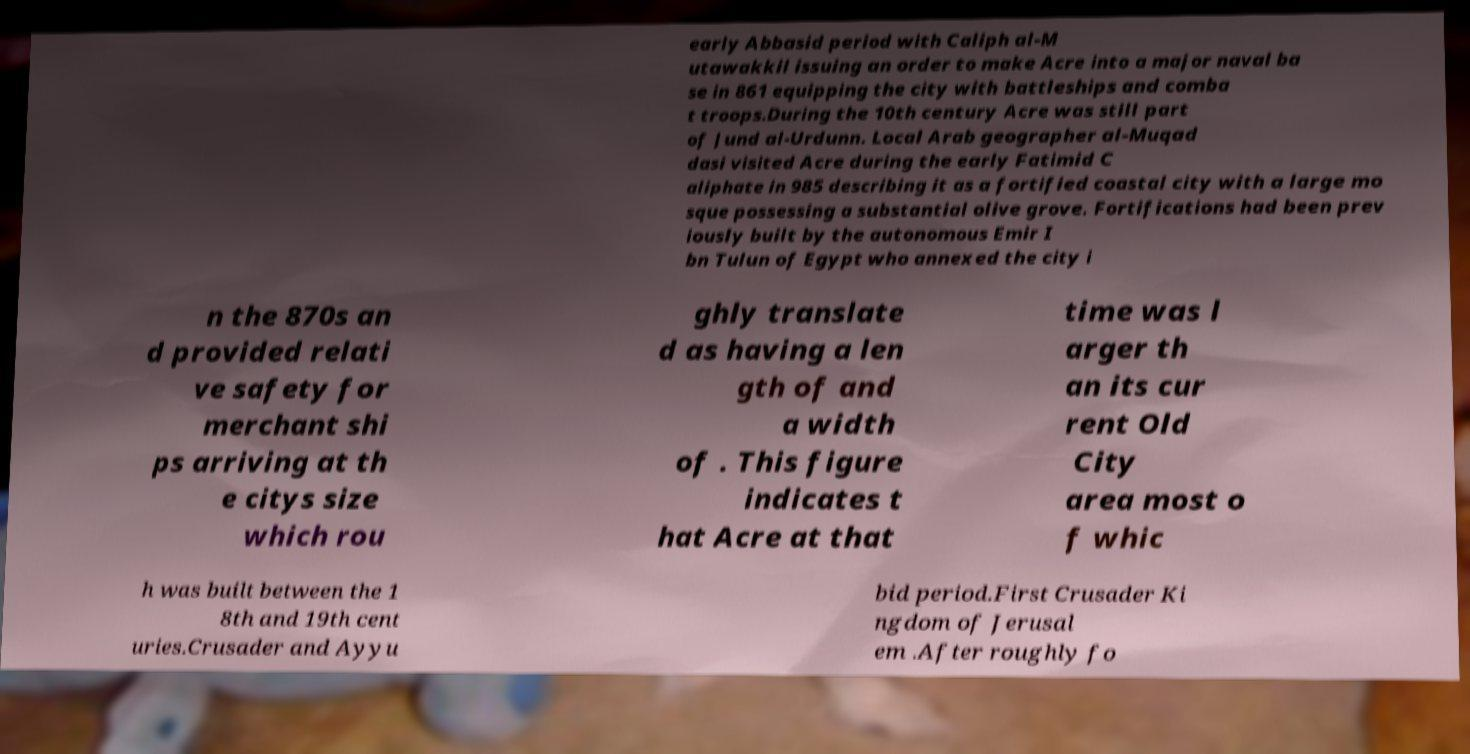There's text embedded in this image that I need extracted. Can you transcribe it verbatim? early Abbasid period with Caliph al-M utawakkil issuing an order to make Acre into a major naval ba se in 861 equipping the city with battleships and comba t troops.During the 10th century Acre was still part of Jund al-Urdunn. Local Arab geographer al-Muqad dasi visited Acre during the early Fatimid C aliphate in 985 describing it as a fortified coastal city with a large mo sque possessing a substantial olive grove. Fortifications had been prev iously built by the autonomous Emir I bn Tulun of Egypt who annexed the city i n the 870s an d provided relati ve safety for merchant shi ps arriving at th e citys size which rou ghly translate d as having a len gth of and a width of . This figure indicates t hat Acre at that time was l arger th an its cur rent Old City area most o f whic h was built between the 1 8th and 19th cent uries.Crusader and Ayyu bid period.First Crusader Ki ngdom of Jerusal em .After roughly fo 